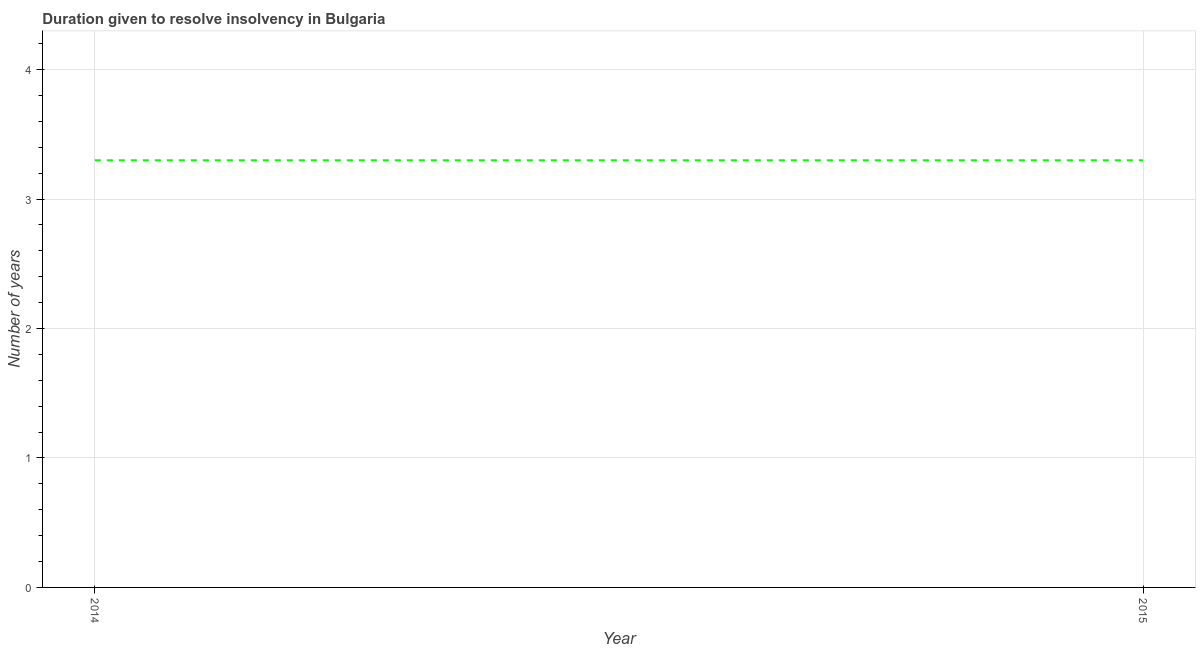Across all years, what is the maximum number of years to resolve insolvency?
Provide a succinct answer. 3.3. In which year was the number of years to resolve insolvency maximum?
Your answer should be compact. 2014. What is the sum of the number of years to resolve insolvency?
Offer a terse response. 6.6. What is the average number of years to resolve insolvency per year?
Make the answer very short. 3.3. What is the median number of years to resolve insolvency?
Make the answer very short. 3.3. Do a majority of the years between 2015 and 2014 (inclusive) have number of years to resolve insolvency greater than 3.8 ?
Your answer should be very brief. No. What is the ratio of the number of years to resolve insolvency in 2014 to that in 2015?
Give a very brief answer. 1. Is the number of years to resolve insolvency in 2014 less than that in 2015?
Provide a short and direct response. No. In how many years, is the number of years to resolve insolvency greater than the average number of years to resolve insolvency taken over all years?
Your answer should be very brief. 0. How many lines are there?
Ensure brevity in your answer.  1. How many years are there in the graph?
Provide a succinct answer. 2. Does the graph contain any zero values?
Offer a very short reply. No. What is the title of the graph?
Offer a terse response. Duration given to resolve insolvency in Bulgaria. What is the label or title of the X-axis?
Keep it short and to the point. Year. What is the label or title of the Y-axis?
Provide a short and direct response. Number of years. What is the Number of years in 2014?
Keep it short and to the point. 3.3. What is the Number of years in 2015?
Offer a terse response. 3.3. What is the ratio of the Number of years in 2014 to that in 2015?
Your answer should be compact. 1. 